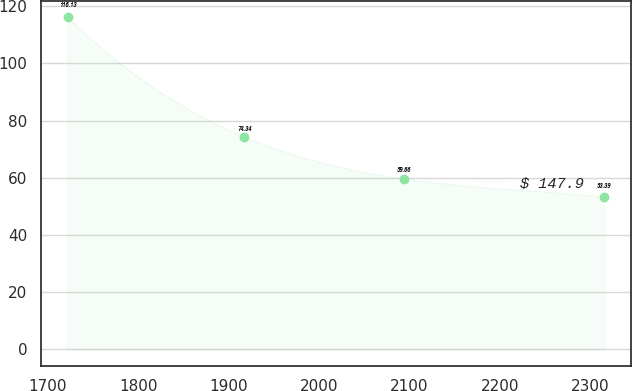Convert chart. <chart><loc_0><loc_0><loc_500><loc_500><line_chart><ecel><fcel>$ 147.9<nl><fcel>1722.01<fcel>116.13<nl><fcel>1917.34<fcel>74.34<nl><fcel>2093.7<fcel>59.66<nl><fcel>2315.24<fcel>53.39<nl></chart> 